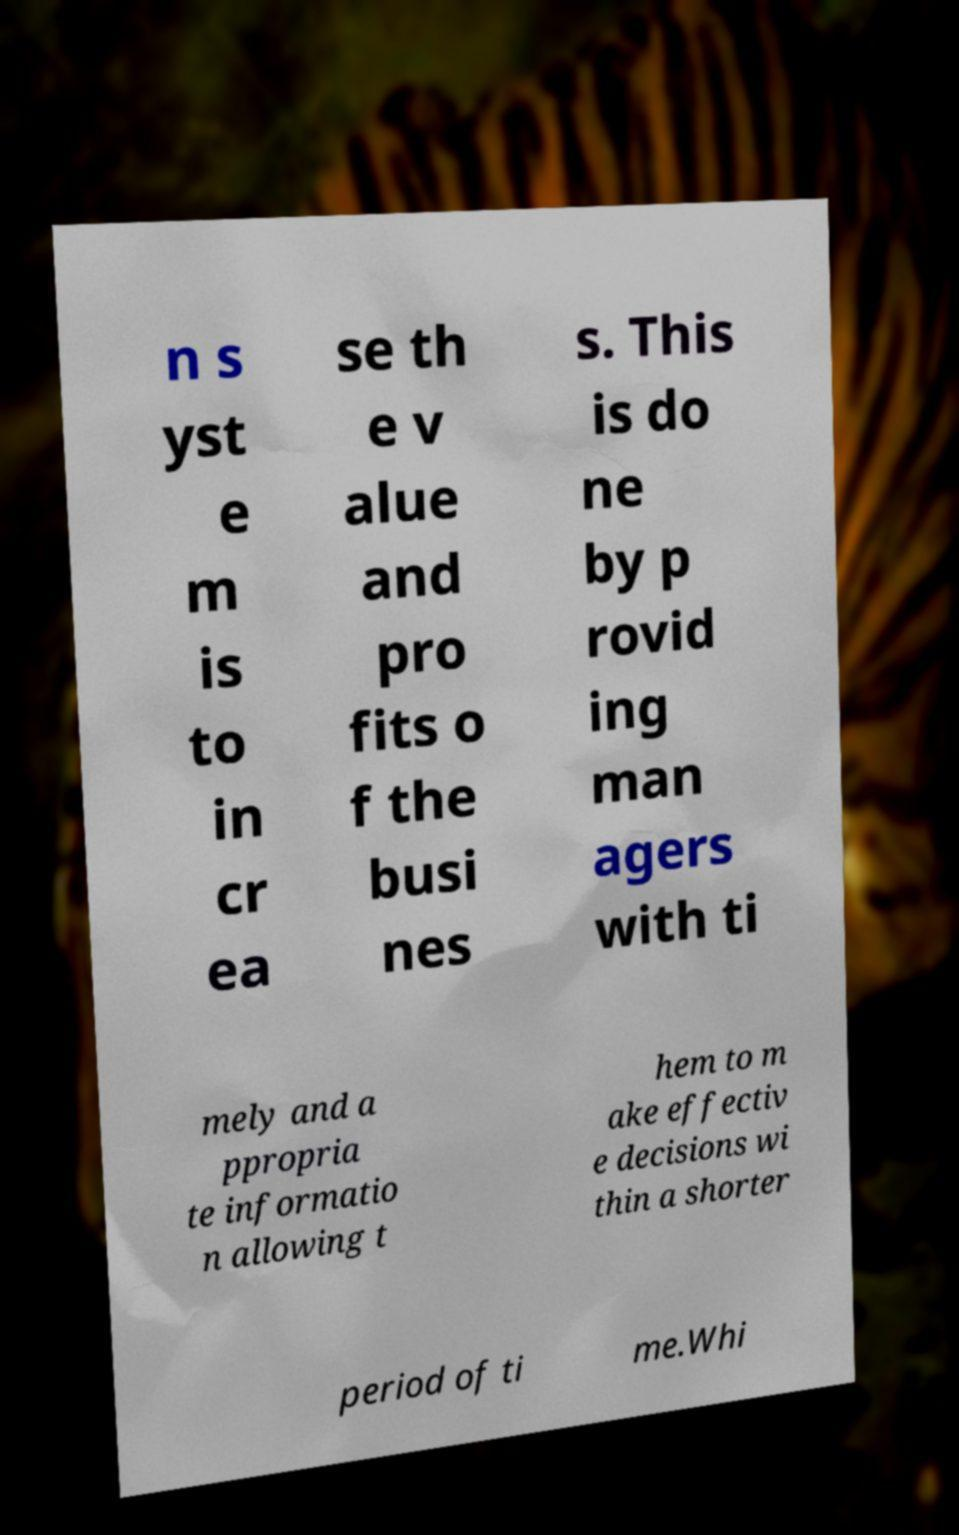For documentation purposes, I need the text within this image transcribed. Could you provide that? n s yst e m is to in cr ea se th e v alue and pro fits o f the busi nes s. This is do ne by p rovid ing man agers with ti mely and a ppropria te informatio n allowing t hem to m ake effectiv e decisions wi thin a shorter period of ti me.Whi 